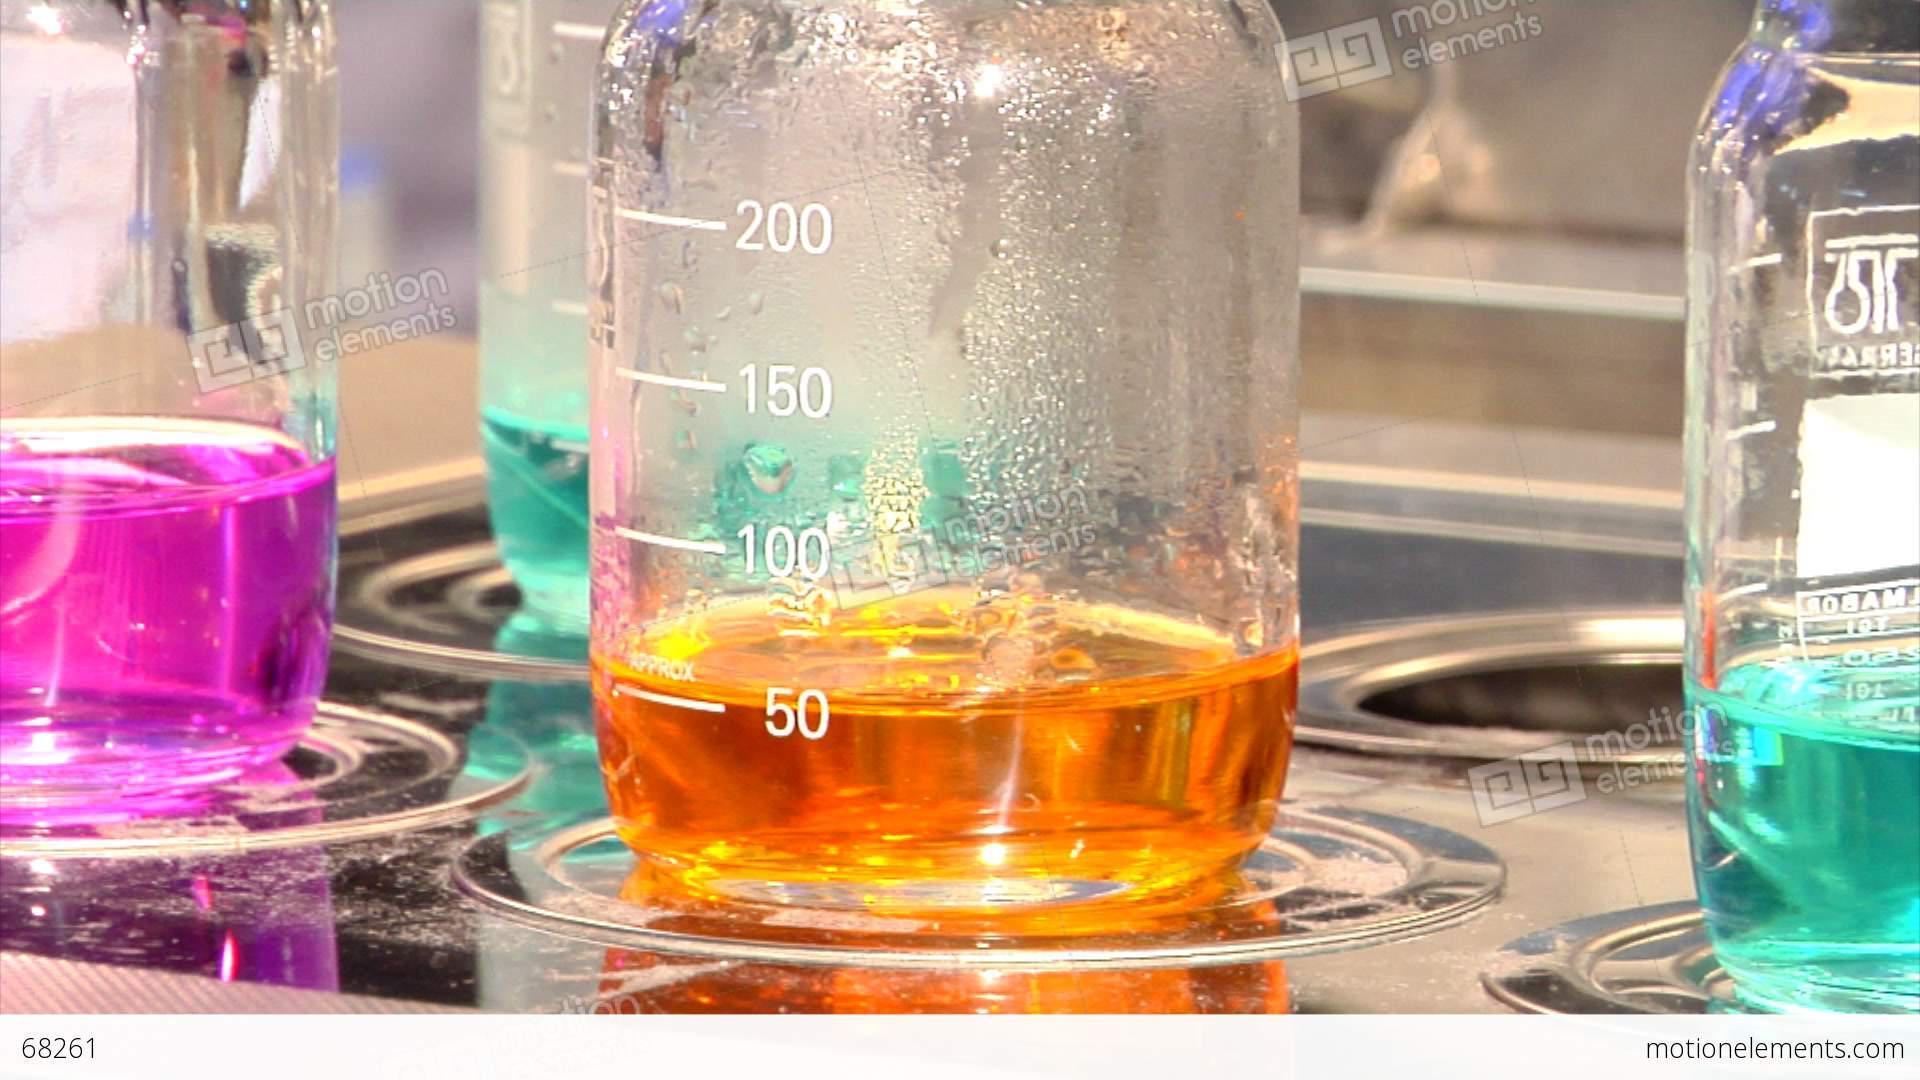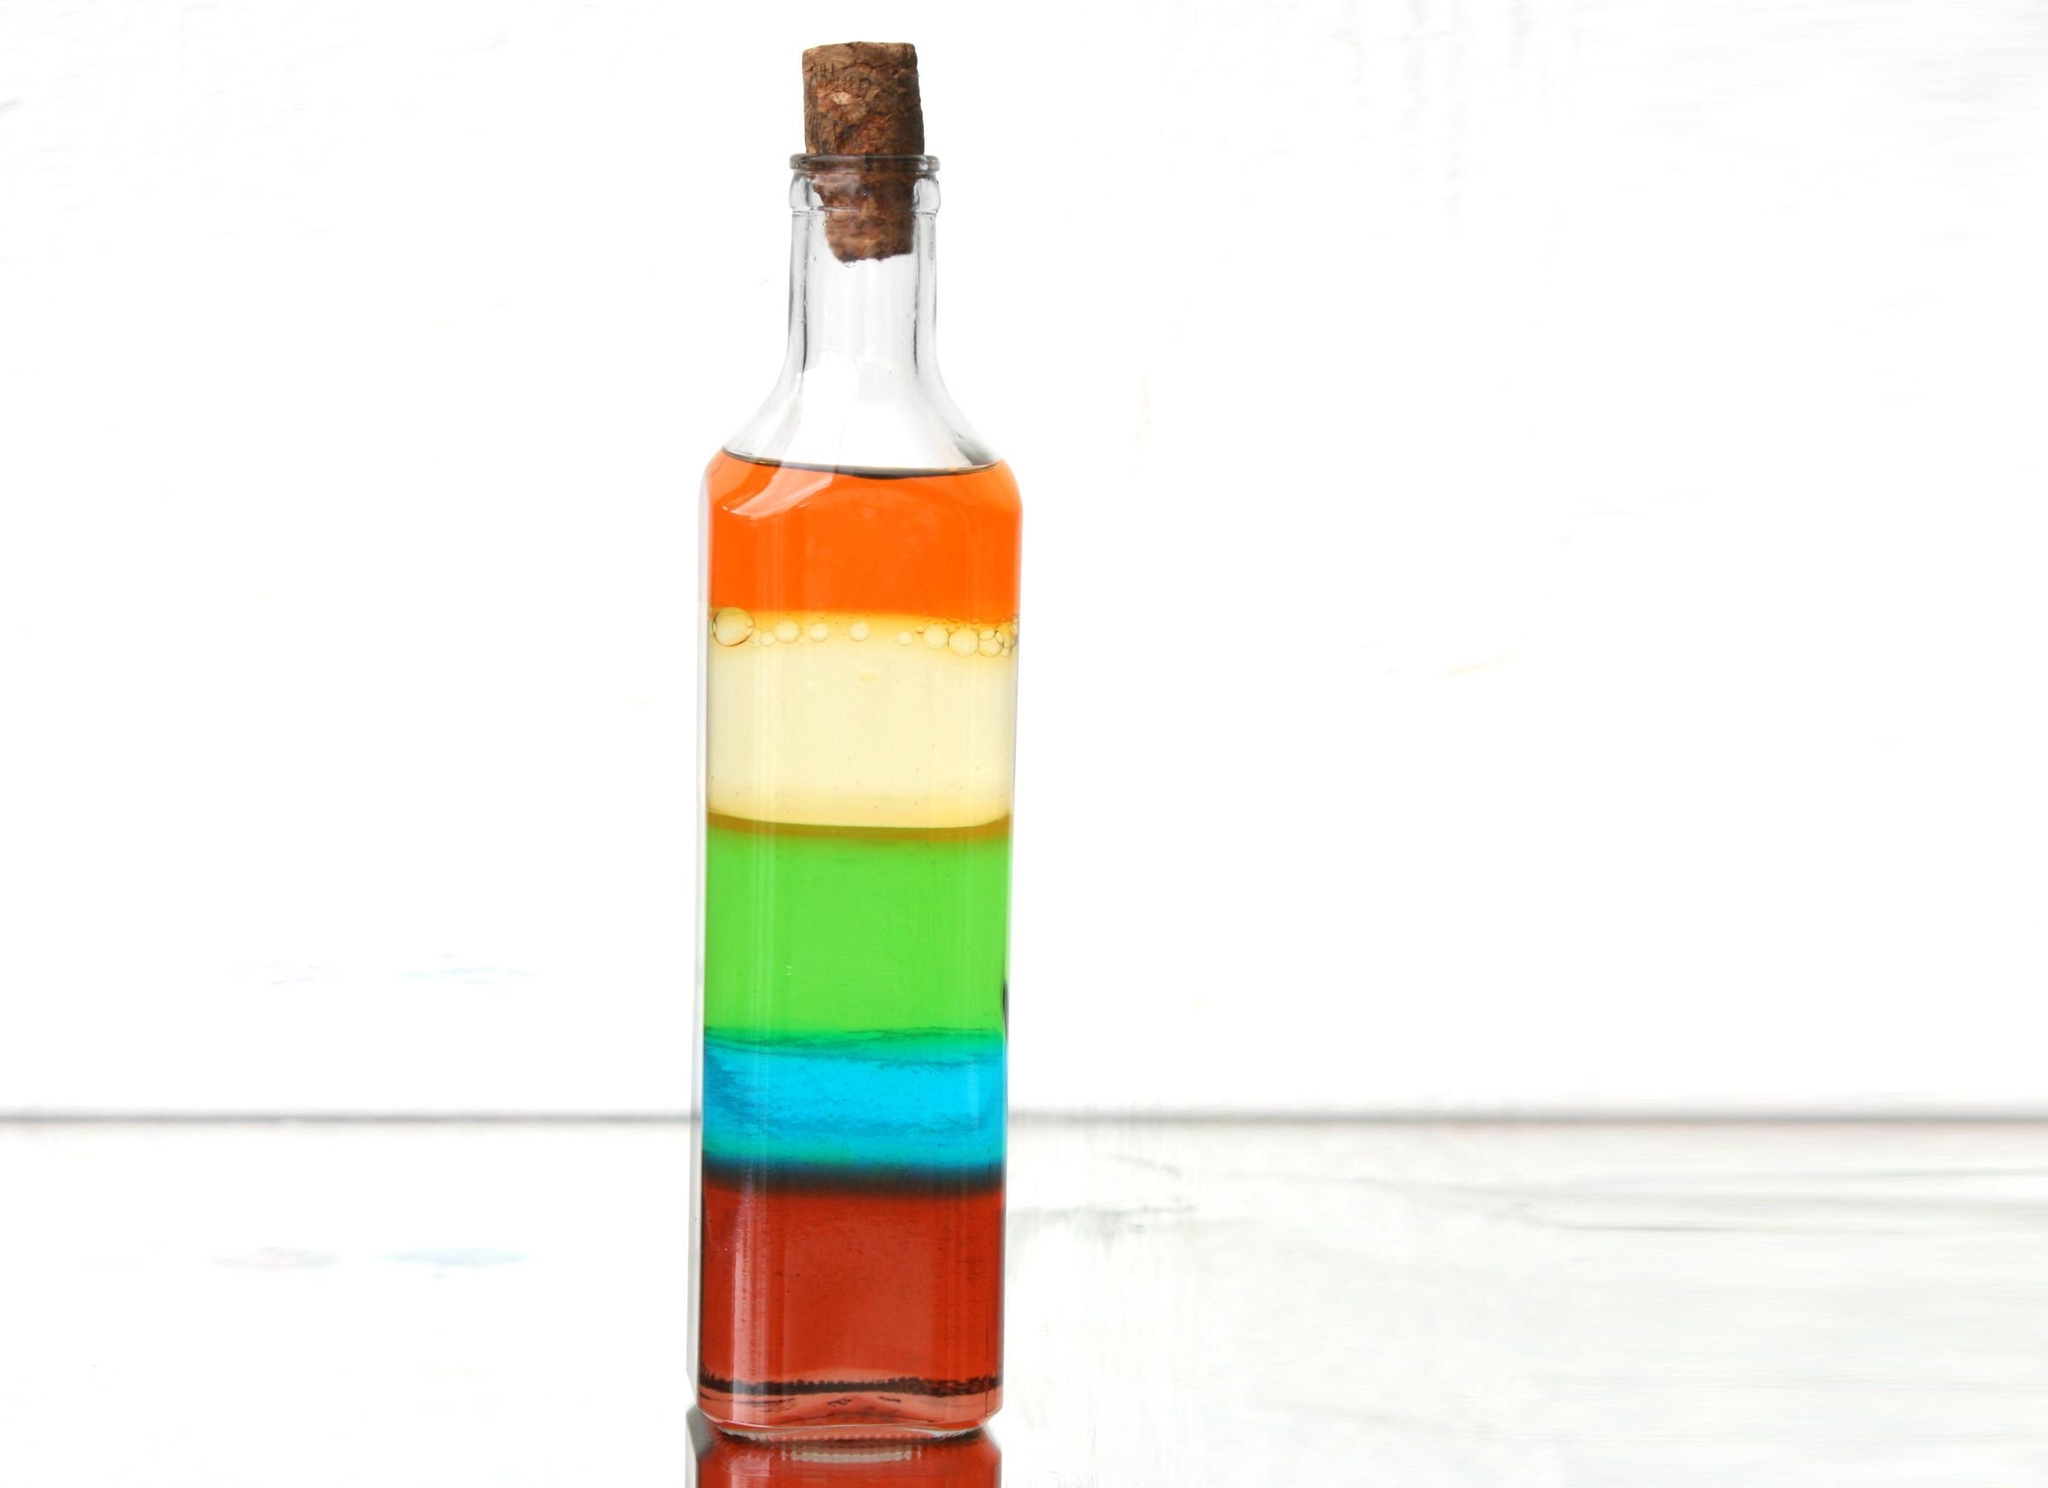The first image is the image on the left, the second image is the image on the right. Assess this claim about the two images: "One image shows a row of no more than five beakers displayed with their bases level, and each beaker contains a different color of liquid.". Correct or not? Answer yes or no. No. The first image is the image on the left, the second image is the image on the right. For the images displayed, is the sentence "Every image shows at least four containers of colored liquid and there are at least four different colors of liquid in each photo." factually correct? Answer yes or no. No. 